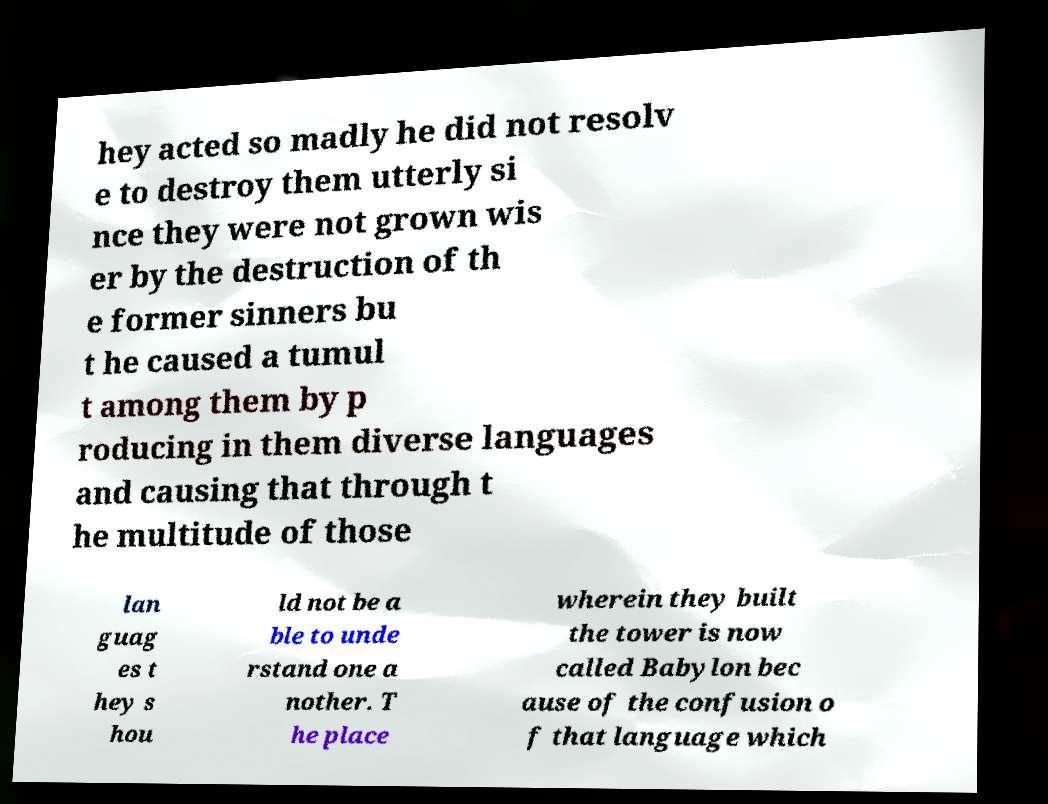Please identify and transcribe the text found in this image. hey acted so madly he did not resolv e to destroy them utterly si nce they were not grown wis er by the destruction of th e former sinners bu t he caused a tumul t among them by p roducing in them diverse languages and causing that through t he multitude of those lan guag es t hey s hou ld not be a ble to unde rstand one a nother. T he place wherein they built the tower is now called Babylon bec ause of the confusion o f that language which 